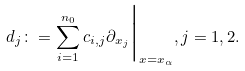<formula> <loc_0><loc_0><loc_500><loc_500>d _ { j } \colon = \sum _ { i = 1 } ^ { n _ { 0 } } c _ { i , j } \partial _ { x _ { j } } \Big | _ { x = x _ { \alpha } } , j = 1 , 2 .</formula> 